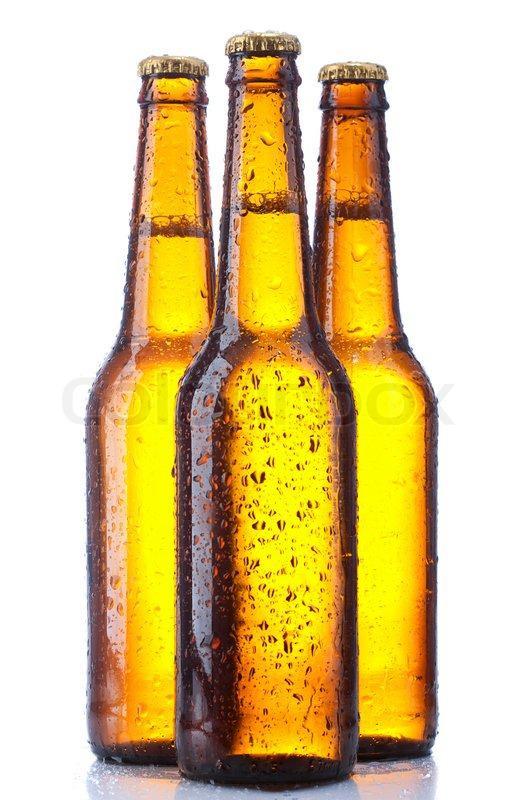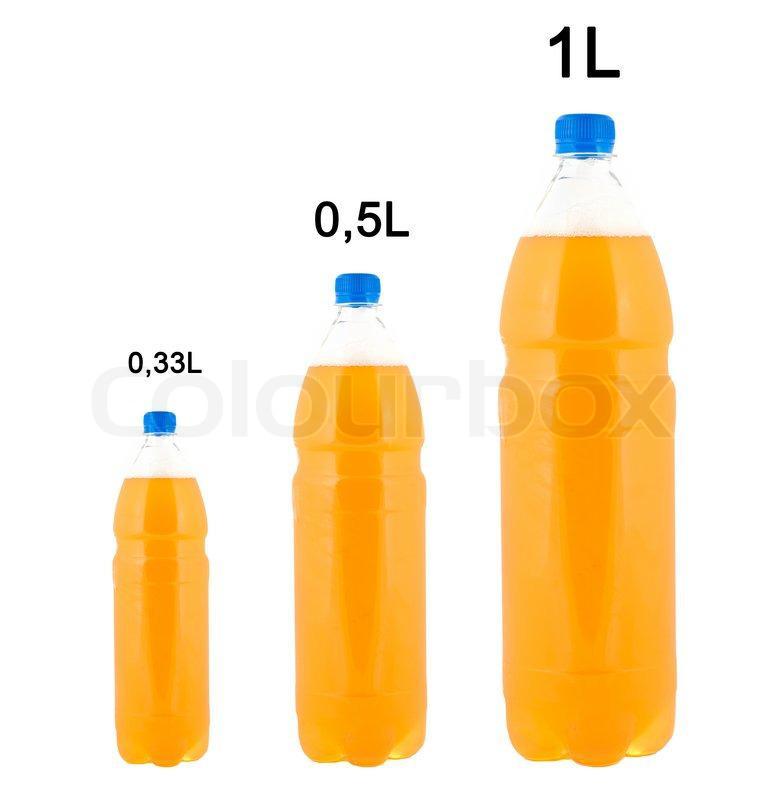The first image is the image on the left, the second image is the image on the right. Evaluate the accuracy of this statement regarding the images: "The bottles in the image on the right have no caps.". Is it true? Answer yes or no. No. 